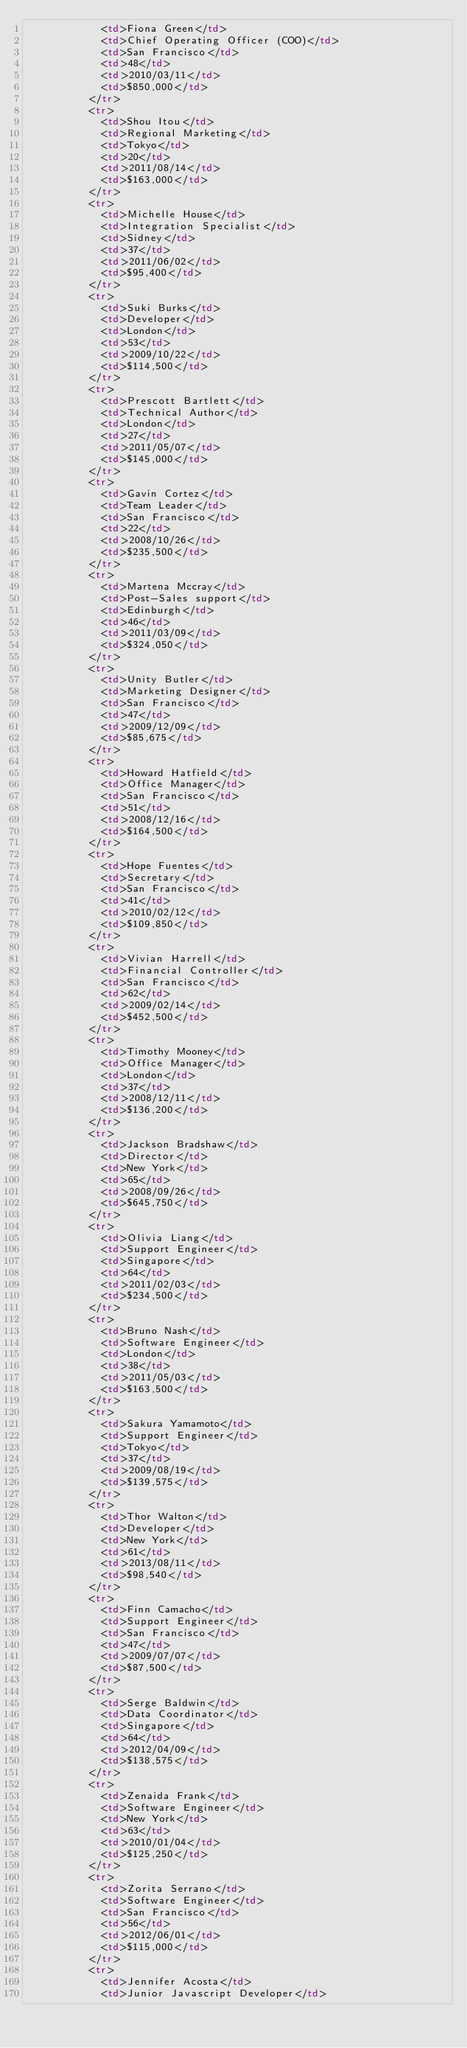Convert code to text. <code><loc_0><loc_0><loc_500><loc_500><_HTML_>						<td>Fiona Green</td>
						<td>Chief Operating Officer (COO)</td>
						<td>San Francisco</td>
						<td>48</td>
						<td>2010/03/11</td>
						<td>$850,000</td>
					</tr>
					<tr>
						<td>Shou Itou</td>
						<td>Regional Marketing</td>
						<td>Tokyo</td>
						<td>20</td>
						<td>2011/08/14</td>
						<td>$163,000</td>
					</tr>
					<tr>
						<td>Michelle House</td>
						<td>Integration Specialist</td>
						<td>Sidney</td>
						<td>37</td>
						<td>2011/06/02</td>
						<td>$95,400</td>
					</tr>
					<tr>
						<td>Suki Burks</td>
						<td>Developer</td>
						<td>London</td>
						<td>53</td>
						<td>2009/10/22</td>
						<td>$114,500</td>
					</tr>
					<tr>
						<td>Prescott Bartlett</td>
						<td>Technical Author</td>
						<td>London</td>
						<td>27</td>
						<td>2011/05/07</td>
						<td>$145,000</td>
					</tr>
					<tr>
						<td>Gavin Cortez</td>
						<td>Team Leader</td>
						<td>San Francisco</td>
						<td>22</td>
						<td>2008/10/26</td>
						<td>$235,500</td>
					</tr>
					<tr>
						<td>Martena Mccray</td>
						<td>Post-Sales support</td>
						<td>Edinburgh</td>
						<td>46</td>
						<td>2011/03/09</td>
						<td>$324,050</td>
					</tr>
					<tr>
						<td>Unity Butler</td>
						<td>Marketing Designer</td>
						<td>San Francisco</td>
						<td>47</td>
						<td>2009/12/09</td>
						<td>$85,675</td>
					</tr>
					<tr>
						<td>Howard Hatfield</td>
						<td>Office Manager</td>
						<td>San Francisco</td>
						<td>51</td>
						<td>2008/12/16</td>
						<td>$164,500</td>
					</tr>
					<tr>
						<td>Hope Fuentes</td>
						<td>Secretary</td>
						<td>San Francisco</td>
						<td>41</td>
						<td>2010/02/12</td>
						<td>$109,850</td>
					</tr>
					<tr>
						<td>Vivian Harrell</td>
						<td>Financial Controller</td>
						<td>San Francisco</td>
						<td>62</td>
						<td>2009/02/14</td>
						<td>$452,500</td>
					</tr>
					<tr>
						<td>Timothy Mooney</td>
						<td>Office Manager</td>
						<td>London</td>
						<td>37</td>
						<td>2008/12/11</td>
						<td>$136,200</td>
					</tr>
					<tr>
						<td>Jackson Bradshaw</td>
						<td>Director</td>
						<td>New York</td>
						<td>65</td>
						<td>2008/09/26</td>
						<td>$645,750</td>
					</tr>
					<tr>
						<td>Olivia Liang</td>
						<td>Support Engineer</td>
						<td>Singapore</td>
						<td>64</td>
						<td>2011/02/03</td>
						<td>$234,500</td>
					</tr>
					<tr>
						<td>Bruno Nash</td>
						<td>Software Engineer</td>
						<td>London</td>
						<td>38</td>
						<td>2011/05/03</td>
						<td>$163,500</td>
					</tr>
					<tr>
						<td>Sakura Yamamoto</td>
						<td>Support Engineer</td>
						<td>Tokyo</td>
						<td>37</td>
						<td>2009/08/19</td>
						<td>$139,575</td>
					</tr>
					<tr>
						<td>Thor Walton</td>
						<td>Developer</td>
						<td>New York</td>
						<td>61</td>
						<td>2013/08/11</td>
						<td>$98,540</td>
					</tr>
					<tr>
						<td>Finn Camacho</td>
						<td>Support Engineer</td>
						<td>San Francisco</td>
						<td>47</td>
						<td>2009/07/07</td>
						<td>$87,500</td>
					</tr>
					<tr>
						<td>Serge Baldwin</td>
						<td>Data Coordinator</td>
						<td>Singapore</td>
						<td>64</td>
						<td>2012/04/09</td>
						<td>$138,575</td>
					</tr>
					<tr>
						<td>Zenaida Frank</td>
						<td>Software Engineer</td>
						<td>New York</td>
						<td>63</td>
						<td>2010/01/04</td>
						<td>$125,250</td>
					</tr>
					<tr>
						<td>Zorita Serrano</td>
						<td>Software Engineer</td>
						<td>San Francisco</td>
						<td>56</td>
						<td>2012/06/01</td>
						<td>$115,000</td>
					</tr>
					<tr>
						<td>Jennifer Acosta</td>
						<td>Junior Javascript Developer</td></code> 